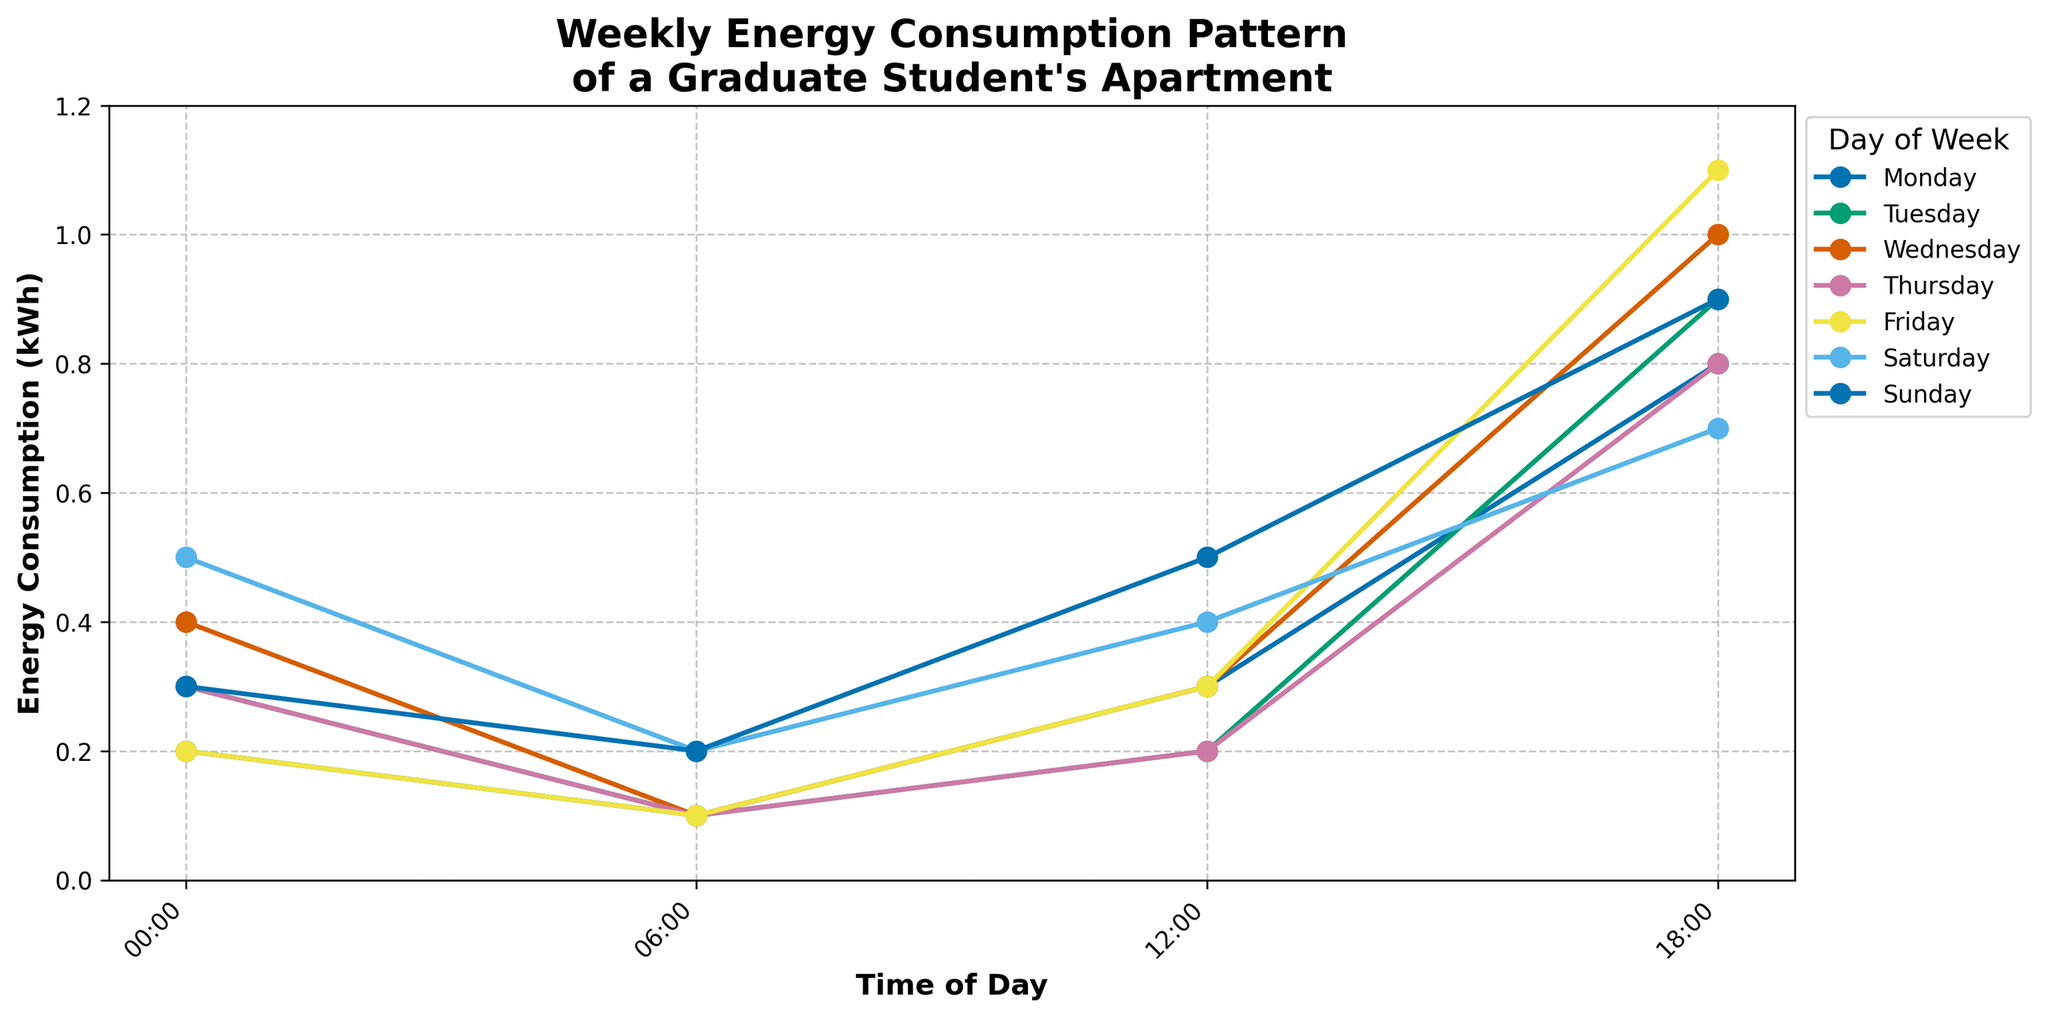Which day has the highest energy consumption at 18:00? Look at the data points for 18:00 across all days and compare their heights. The tallest point corresponds to Friday, where the energy consumption is 1.1 kWh.
Answer: Friday How much higher is Wednesday's energy consumption at midnight compared to Monday's? Look at the data points at 00:00 for both Monday and Wednesday. Subtract Monday’s consumption (0.2 kWh) from Wednesday’s consumption (0.4 kWh). 0.4 - 0.2 = 0.2 kWh.
Answer: 0.2 kWh On which day is the energy consumption at 12:00 the lowest? Compare the data points at 12:00 over all days. Tuesday and Thursday both have the lowest value of 0.2 kWh.
Answer: Tuesday and Thursday What is the average energy consumption at 06:00 over the entire week? Sum up the energy consumption values at 06:00 for all days: 0.1 + 0.1 + 0.1 + 0.1 + 0.1 + 0.2 + 0.2 = 0.9 kWh. Divide by the number of days: 0.9 / 7 ≈ 0.129 kWh.
Answer: 0.129 kWh Which day has the largest increase in energy consumption between 12:00 and 18:00? Calculate the rise in energy consumption from 12:00 to 18:00 for each day, then identify the day with the maximum increase:
Monday (0.8 - 0.3 = 0.5), Tuesday (0.9 - 0.2 = 0.7), Wednesday (1.0 - 0.3 = 0.7), Thursday (0.8 - 0.2 = 0.6), Friday (1.1 - 0.3 = 0.8), Saturday (0.7 - 0.4 = 0.3), Sunday (0.9 - 0.5 = 0.4). The largest increase is on Friday.
Answer: Friday What is the median energy consumption at midnight throughout the week? List the values for consumption at 00:00: 0.2, 0.3, 0.4, 0.3, 0.2, 0.5, 0.3. Organize them in ascending order: 0.2, 0.2, 0.3, 0.3, 0.3, 0.4, 0.5. The median value is the middle one: 0.3 kWh.
Answer: 0.3 kWh 